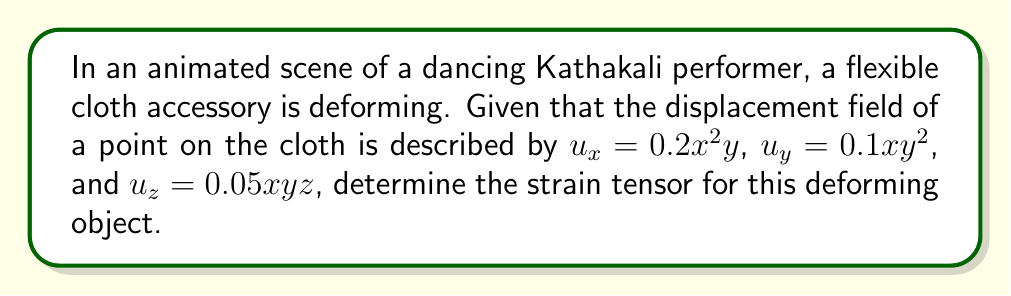Can you solve this math problem? To determine the strain tensor for the deforming animated object, we need to follow these steps:

1) The strain tensor $\varepsilon_{ij}$ is defined as:

   $$\varepsilon_{ij} = \frac{1}{2}\left(\frac{\partial u_i}{\partial x_j} + \frac{\partial u_j}{\partial x_i}\right)$$

2) We need to calculate all the partial derivatives:

   $$\frac{\partial u_x}{\partial x} = 0.4xy, \frac{\partial u_x}{\partial y} = 0.2x^2, \frac{\partial u_x}{\partial z} = 0$$
   $$\frac{\partial u_y}{\partial x} = 0.1y^2, \frac{\partial u_y}{\partial y} = 0.2xy, \frac{\partial u_y}{\partial z} = 0$$
   $$\frac{\partial u_z}{\partial x} = 0.05yz, \frac{\partial u_z}{\partial y} = 0.05xz, \frac{\partial u_z}{\partial z} = 0.05xy$$

3) Now, we can calculate each component of the strain tensor:

   $$\varepsilon_{xx} = \frac{\partial u_x}{\partial x} = 0.4xy$$
   
   $$\varepsilon_{yy} = \frac{\partial u_y}{\partial y} = 0.2xy$$
   
   $$\varepsilon_{zz} = \frac{\partial u_z}{\partial z} = 0.05xy$$
   
   $$\varepsilon_{xy} = \varepsilon_{yx} = \frac{1}{2}\left(\frac{\partial u_x}{\partial y} + \frac{\partial u_y}{\partial x}\right) = \frac{1}{2}(0.2x^2 + 0.1y^2)$$
   
   $$\varepsilon_{xz} = \varepsilon_{zx} = \frac{1}{2}\left(\frac{\partial u_x}{\partial z} + \frac{\partial u_z}{\partial x}\right) = \frac{1}{2}(0 + 0.05yz) = 0.025yz$$
   
   $$\varepsilon_{yz} = \varepsilon_{zy} = \frac{1}{2}\left(\frac{\partial u_y}{\partial z} + \frac{\partial u_z}{\partial y}\right) = \frac{1}{2}(0 + 0.05xz) = 0.025xz$$

4) The strain tensor can be written in matrix form as:

   $$\varepsilon = \begin{bmatrix}
   0.4xy & 0.1x^2 + 0.05y^2 & 0.025yz \\
   0.1x^2 + 0.05y^2 & 0.2xy & 0.025xz \\
   0.025yz & 0.025xz & 0.05xy
   \end{bmatrix}$$
Answer: $$\varepsilon = \begin{bmatrix}
0.4xy & 0.1x^2 + 0.05y^2 & 0.025yz \\
0.1x^2 + 0.05y^2 & 0.2xy & 0.025xz \\
0.025yz & 0.025xz & 0.05xy
\end{bmatrix}$$ 